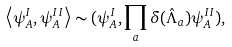Convert formula to latex. <formula><loc_0><loc_0><loc_500><loc_500>\left < \psi _ { A } ^ { I } , \psi _ { A } ^ { I I } \right > \sim ( \psi _ { A } ^ { I } , \prod _ { a } \delta ( \hat { \Lambda } _ { a } ) \psi _ { A } ^ { I I } ) ,</formula> 